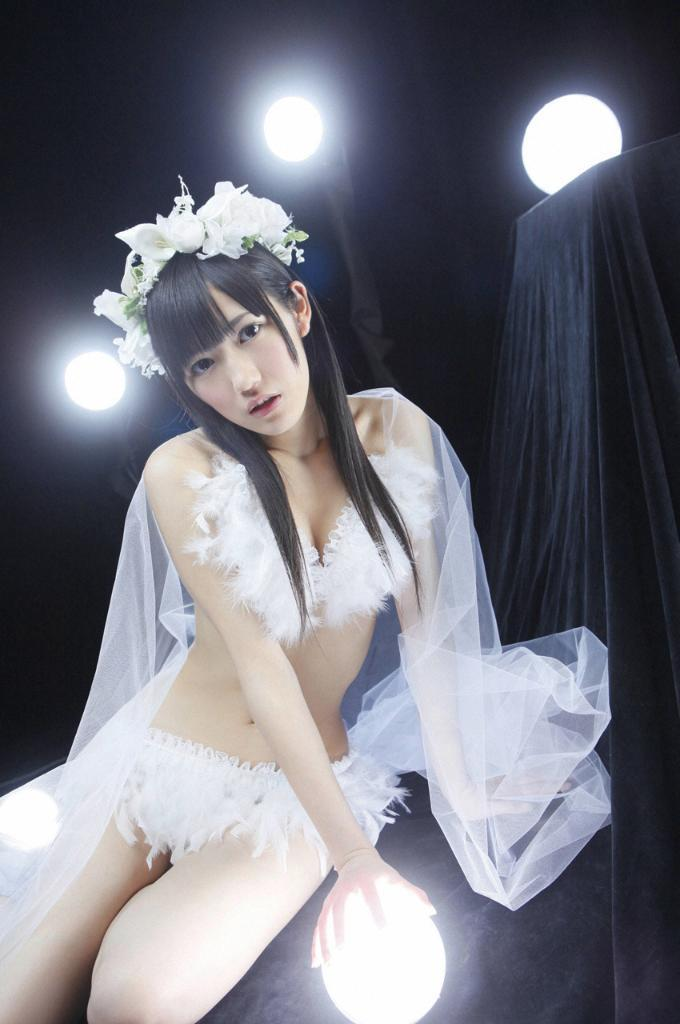Who is the main subject in the image? There is a girl in the image. What is the girl holding in the image? The girl is holding a light bulb. What can be seen in the background of the image? There are spotlights in the background of the image. What is the color of the curtain on the right side of the image? There appears to be a black curtain on the right side of the image. How does the girl interact with the waves in the image? There are no waves present in the image; it features a girl holding a light bulb with spotlights and a black curtain in the background. 